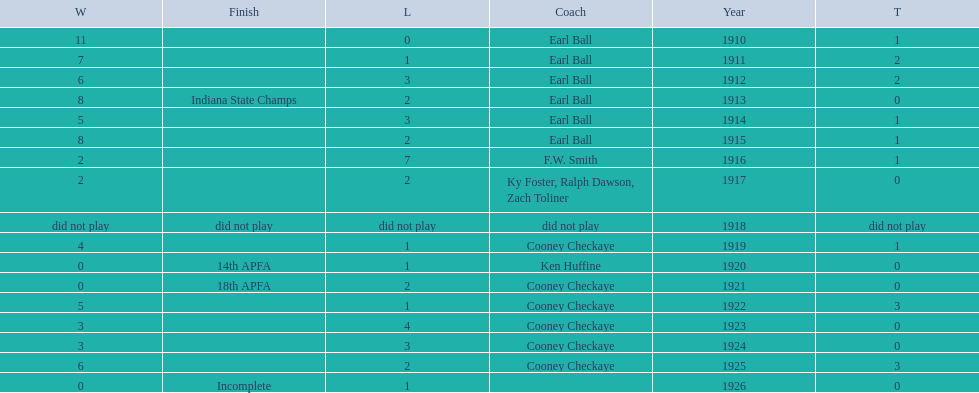How many years did earl ball coach the muncie flyers? 6. 